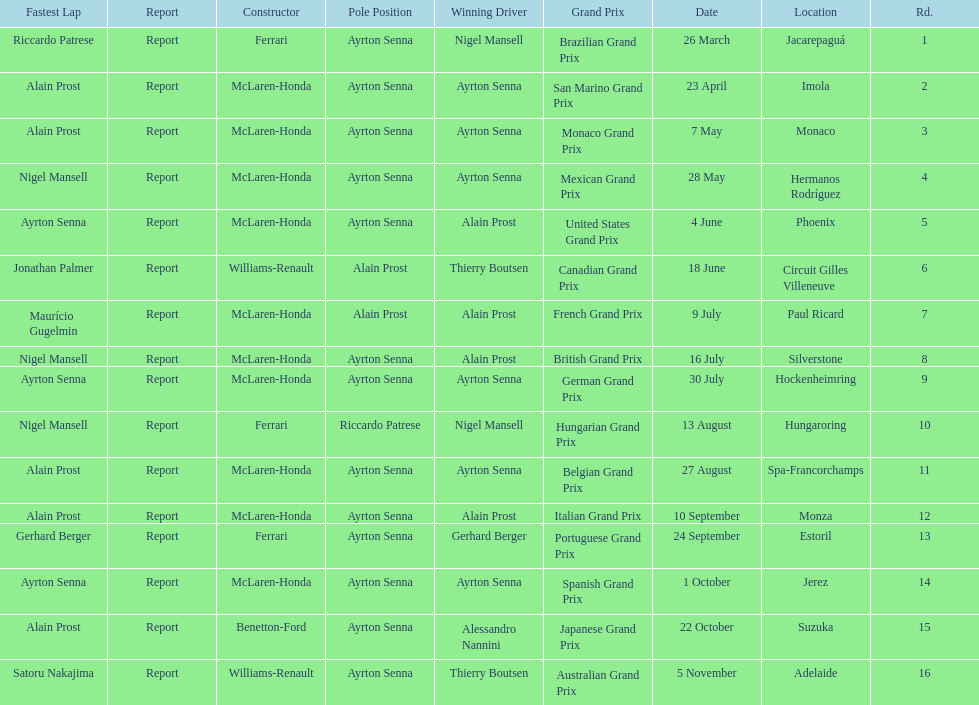How many times was ayrton senna in pole position? 13. 